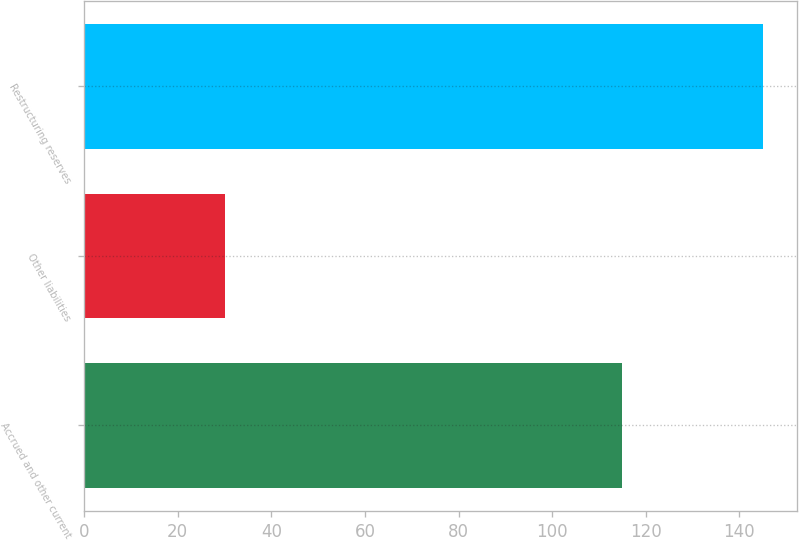Convert chart. <chart><loc_0><loc_0><loc_500><loc_500><bar_chart><fcel>Accrued and other current<fcel>Other liabilities<fcel>Restructuring reserves<nl><fcel>115<fcel>30<fcel>145<nl></chart> 